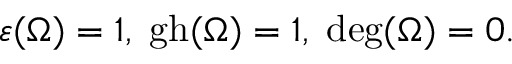<formula> <loc_0><loc_0><loc_500><loc_500>\varepsilon ( \Omega ) = 1 , \, g h ( \Omega ) = 1 , \, d e g ( \Omega ) = 0 .</formula> 